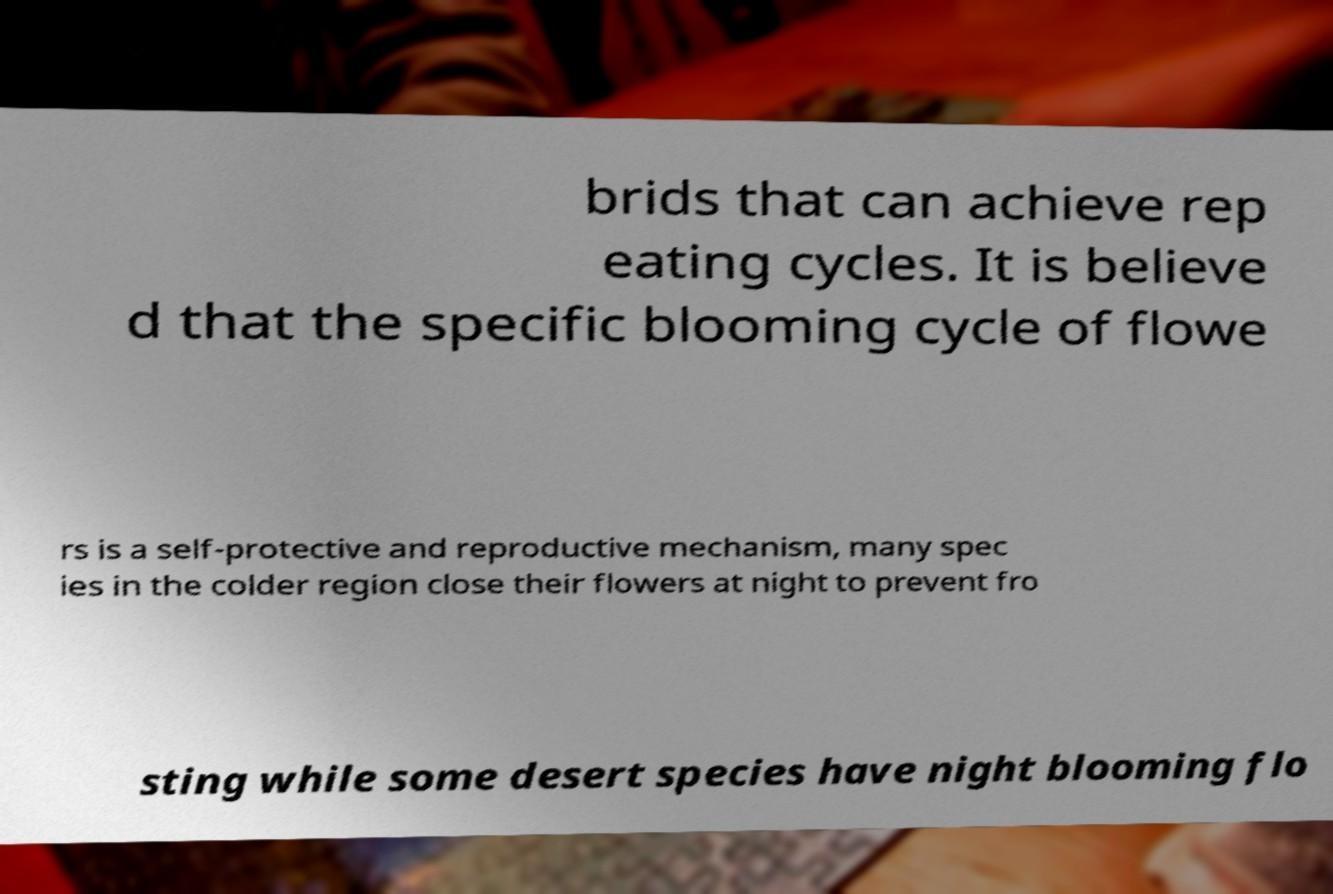What messages or text are displayed in this image? I need them in a readable, typed format. brids that can achieve rep eating cycles. It is believe d that the specific blooming cycle of flowe rs is a self-protective and reproductive mechanism, many spec ies in the colder region close their flowers at night to prevent fro sting while some desert species have night blooming flo 